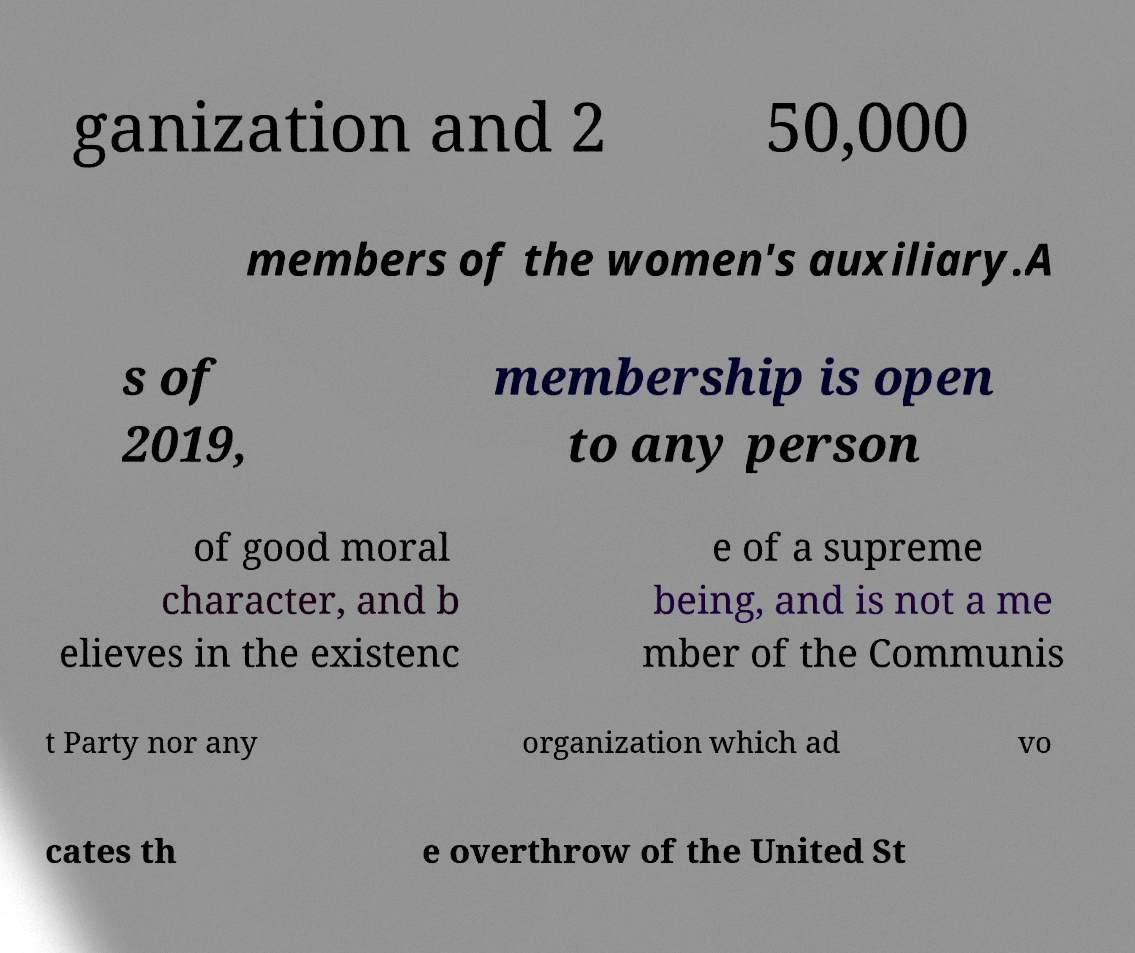Please read and relay the text visible in this image. What does it say? ganization and 2 50,000 members of the women's auxiliary.A s of 2019, membership is open to any person of good moral character, and b elieves in the existenc e of a supreme being, and is not a me mber of the Communis t Party nor any organization which ad vo cates th e overthrow of the United St 